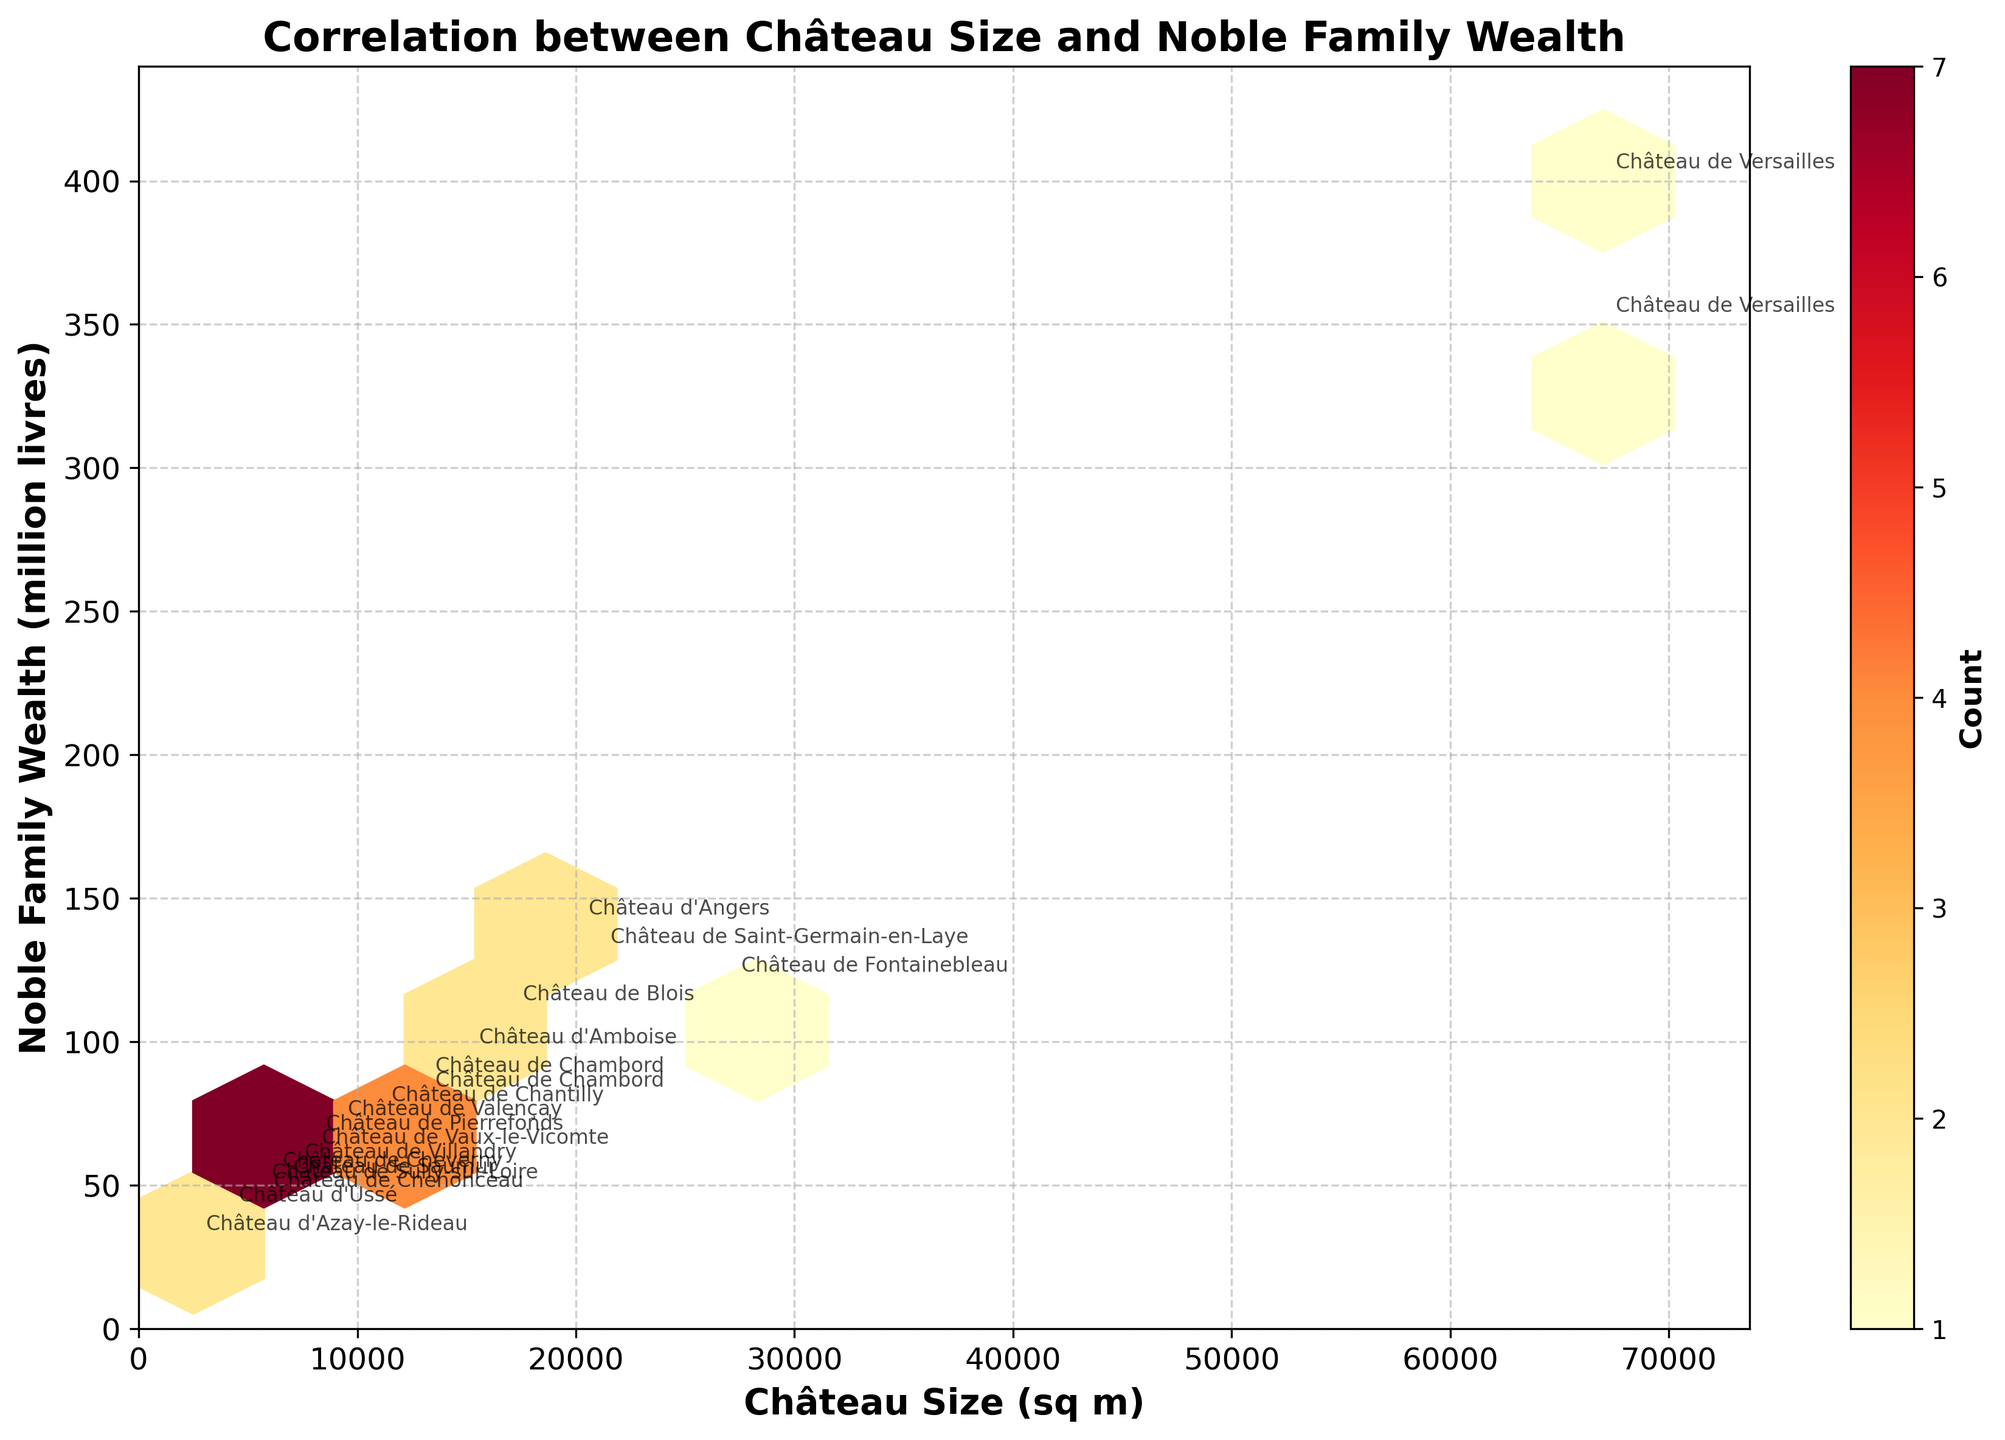What is the title of the plot? The title of the plot is shown at the top of the figure and provides an overview of what the plot is about.
Answer: Correlation between Château Size and Noble Family Wealth What does the color intensity in the hexagonal bins represent? The color intensity in the hexagonal bins represents the count of data points within each bin, with more intense colors indicating a higher count.
Answer: Count of data points What are the axes labels in the figure? The x-axis is labeled 'Château Size (sq m)' and the y-axis is labeled 'Noble Family Wealth (million livres)'. These labels indicate what each axis represents in the plot.
Answer: Château Size (sq m) and Noble Family Wealth (million livres) Which château is observed to have the largest size and wealth concurrently? By checking the annotations and positions of data points, Château de Versailles appears to have both the largest size and wealth at two different periods.
Answer: Château de Versailles How many châteaux have a wealth greater than 100 million livres? We can count the number of hexagonal bins or data points located above the 100 million livres mark on the y-axis. Based on the annotations, there are four such châteaux: Château de Versailles (twice at different periods), Château d'Angers, and Château de Fontainebleau.
Answer: Four Which château has a size of around 7,800 square meters and an associated wealth of around 60 million livres? By studying the annotations and positions of data points, Château de Vaux-le-Vicomte fits this description.
Answer: Château de Vaux-le-Vicomte How does the wealth of Château de Versailles in 1750 compare to 1682? By comparing the annotations for Château de Versailles at both periods, we observe that its wealth increased from 350 million livres in 1682 to 400 million livres in 1750.
Answer: Increased Are there any outliers in the plot? Outliers can be identified by looking for data points far from clusters. Château de Versailles is an outlier with significantly higher size and wealth compared to others.
Answer: Château de Versailles What does a hexagon with a high count indicate about the relationship between size and wealth? A hexagon with a high count indicates a common size-wealth combination among the châteaux, suggesting a prevalent pattern or typical relationship between these two variables.
Answer: Common size-wealth combination What is the relationship between château size and noble family wealth observed from the plot? Most châteaux show a positive correlation where larger château sizes tend to be associated with higher noble family wealth, as indicated by the trend of data points.
Answer: Positive correlation 